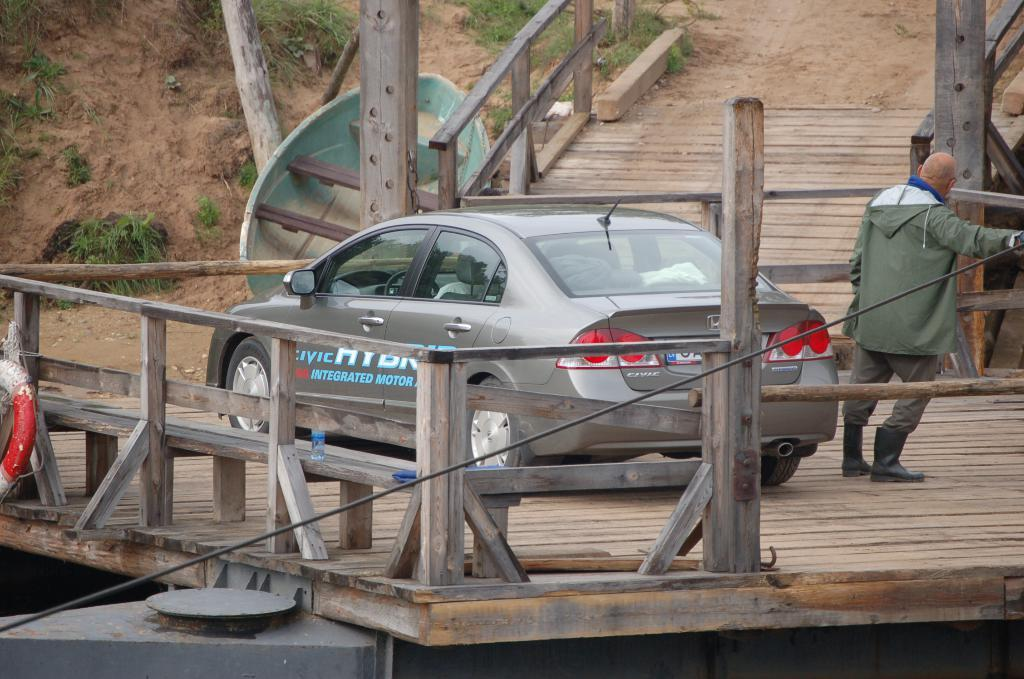What type of vehicle is in the image? There is a vehicle in the image, but the specific type is not mentioned. What is the person on in the image? The person is on a wooden platform in the image. What separates the area in the image? There is a fence in the image. What type of ground is visible in the image? There is grass in the image. What else can be seen in the image besides the vehicle, person, fence, and grass? There are some objects in the image. What type of education does the person on the wooden platform have in the image? There is no information about the person's education in the image. What impulse caused the vehicle to move in the image? There is no information about the vehicle's movement or any impulse in the image. 